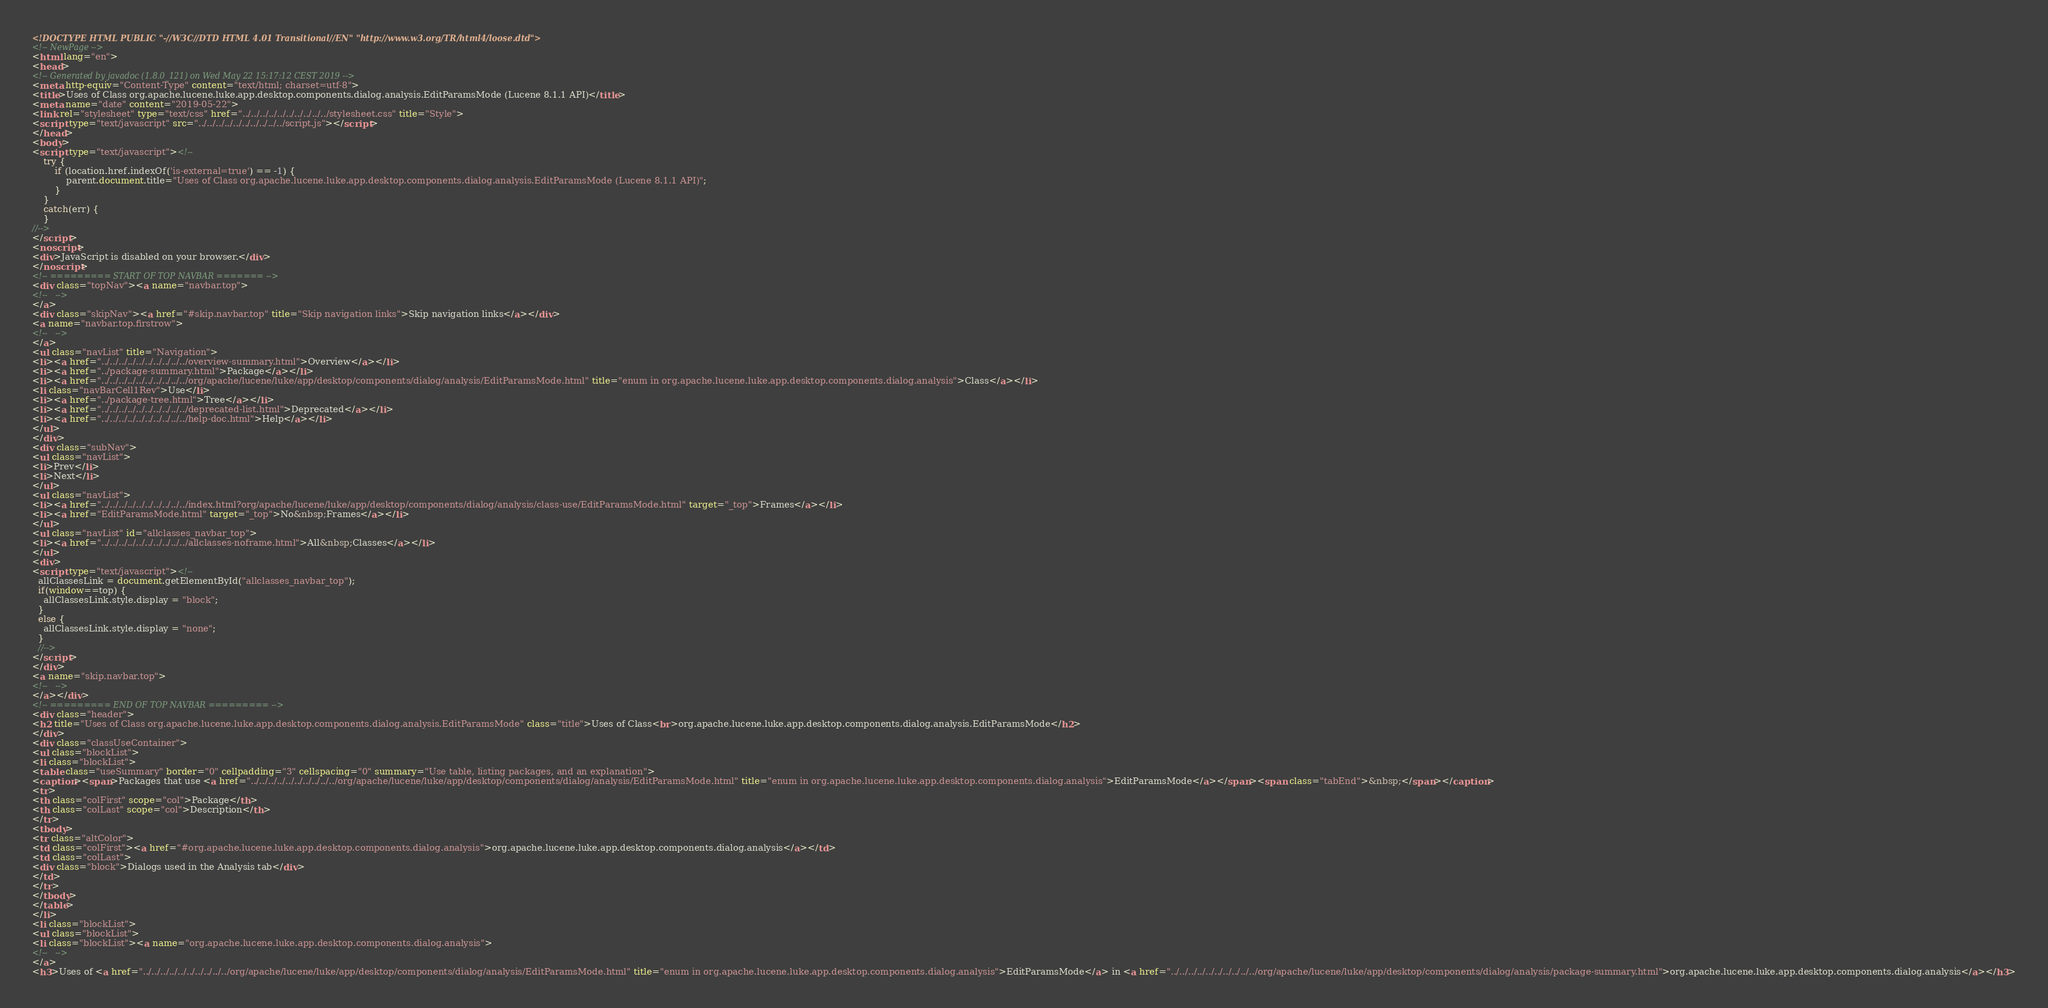Convert code to text. <code><loc_0><loc_0><loc_500><loc_500><_HTML_><!DOCTYPE HTML PUBLIC "-//W3C//DTD HTML 4.01 Transitional//EN" "http://www.w3.org/TR/html4/loose.dtd">
<!-- NewPage -->
<html lang="en">
<head>
<!-- Generated by javadoc (1.8.0_121) on Wed May 22 15:17:12 CEST 2019 -->
<meta http-equiv="Content-Type" content="text/html; charset=utf-8">
<title>Uses of Class org.apache.lucene.luke.app.desktop.components.dialog.analysis.EditParamsMode (Lucene 8.1.1 API)</title>
<meta name="date" content="2019-05-22">
<link rel="stylesheet" type="text/css" href="../../../../../../../../../../stylesheet.css" title="Style">
<script type="text/javascript" src="../../../../../../../../../../script.js"></script>
</head>
<body>
<script type="text/javascript"><!--
    try {
        if (location.href.indexOf('is-external=true') == -1) {
            parent.document.title="Uses of Class org.apache.lucene.luke.app.desktop.components.dialog.analysis.EditParamsMode (Lucene 8.1.1 API)";
        }
    }
    catch(err) {
    }
//-->
</script>
<noscript>
<div>JavaScript is disabled on your browser.</div>
</noscript>
<!-- ========= START OF TOP NAVBAR ======= -->
<div class="topNav"><a name="navbar.top">
<!--   -->
</a>
<div class="skipNav"><a href="#skip.navbar.top" title="Skip navigation links">Skip navigation links</a></div>
<a name="navbar.top.firstrow">
<!--   -->
</a>
<ul class="navList" title="Navigation">
<li><a href="../../../../../../../../../../overview-summary.html">Overview</a></li>
<li><a href="../package-summary.html">Package</a></li>
<li><a href="../../../../../../../../../../org/apache/lucene/luke/app/desktop/components/dialog/analysis/EditParamsMode.html" title="enum in org.apache.lucene.luke.app.desktop.components.dialog.analysis">Class</a></li>
<li class="navBarCell1Rev">Use</li>
<li><a href="../package-tree.html">Tree</a></li>
<li><a href="../../../../../../../../../../deprecated-list.html">Deprecated</a></li>
<li><a href="../../../../../../../../../../help-doc.html">Help</a></li>
</ul>
</div>
<div class="subNav">
<ul class="navList">
<li>Prev</li>
<li>Next</li>
</ul>
<ul class="navList">
<li><a href="../../../../../../../../../../index.html?org/apache/lucene/luke/app/desktop/components/dialog/analysis/class-use/EditParamsMode.html" target="_top">Frames</a></li>
<li><a href="EditParamsMode.html" target="_top">No&nbsp;Frames</a></li>
</ul>
<ul class="navList" id="allclasses_navbar_top">
<li><a href="../../../../../../../../../../allclasses-noframe.html">All&nbsp;Classes</a></li>
</ul>
<div>
<script type="text/javascript"><!--
  allClassesLink = document.getElementById("allclasses_navbar_top");
  if(window==top) {
    allClassesLink.style.display = "block";
  }
  else {
    allClassesLink.style.display = "none";
  }
  //-->
</script>
</div>
<a name="skip.navbar.top">
<!--   -->
</a></div>
<!-- ========= END OF TOP NAVBAR ========= -->
<div class="header">
<h2 title="Uses of Class org.apache.lucene.luke.app.desktop.components.dialog.analysis.EditParamsMode" class="title">Uses of Class<br>org.apache.lucene.luke.app.desktop.components.dialog.analysis.EditParamsMode</h2>
</div>
<div class="classUseContainer">
<ul class="blockList">
<li class="blockList">
<table class="useSummary" border="0" cellpadding="3" cellspacing="0" summary="Use table, listing packages, and an explanation">
<caption><span>Packages that use <a href="../../../../../../../../../../org/apache/lucene/luke/app/desktop/components/dialog/analysis/EditParamsMode.html" title="enum in org.apache.lucene.luke.app.desktop.components.dialog.analysis">EditParamsMode</a></span><span class="tabEnd">&nbsp;</span></caption>
<tr>
<th class="colFirst" scope="col">Package</th>
<th class="colLast" scope="col">Description</th>
</tr>
<tbody>
<tr class="altColor">
<td class="colFirst"><a href="#org.apache.lucene.luke.app.desktop.components.dialog.analysis">org.apache.lucene.luke.app.desktop.components.dialog.analysis</a></td>
<td class="colLast">
<div class="block">Dialogs used in the Analysis tab</div>
</td>
</tr>
</tbody>
</table>
</li>
<li class="blockList">
<ul class="blockList">
<li class="blockList"><a name="org.apache.lucene.luke.app.desktop.components.dialog.analysis">
<!--   -->
</a>
<h3>Uses of <a href="../../../../../../../../../../org/apache/lucene/luke/app/desktop/components/dialog/analysis/EditParamsMode.html" title="enum in org.apache.lucene.luke.app.desktop.components.dialog.analysis">EditParamsMode</a> in <a href="../../../../../../../../../../org/apache/lucene/luke/app/desktop/components/dialog/analysis/package-summary.html">org.apache.lucene.luke.app.desktop.components.dialog.analysis</a></h3></code> 